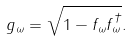<formula> <loc_0><loc_0><loc_500><loc_500>g _ { \omega } = \sqrt { 1 - f _ { \omega } f _ { \omega } ^ { \dagger } } .</formula> 